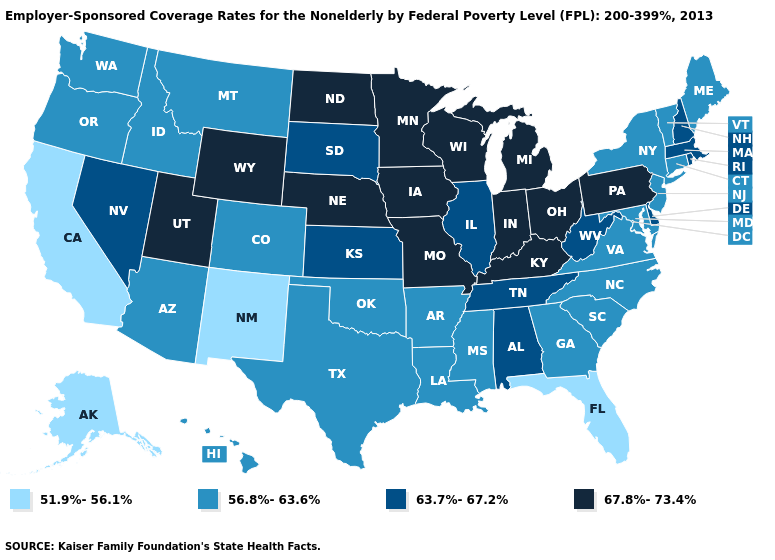What is the value of Colorado?
Quick response, please. 56.8%-63.6%. Does New Mexico have the lowest value in the USA?
Keep it brief. Yes. What is the highest value in the USA?
Answer briefly. 67.8%-73.4%. Does the map have missing data?
Answer briefly. No. Name the states that have a value in the range 56.8%-63.6%?
Answer briefly. Arizona, Arkansas, Colorado, Connecticut, Georgia, Hawaii, Idaho, Louisiana, Maine, Maryland, Mississippi, Montana, New Jersey, New York, North Carolina, Oklahoma, Oregon, South Carolina, Texas, Vermont, Virginia, Washington. Does Kentucky have the highest value in the South?
Concise answer only. Yes. Does North Dakota have a lower value than Minnesota?
Concise answer only. No. Name the states that have a value in the range 51.9%-56.1%?
Quick response, please. Alaska, California, Florida, New Mexico. Among the states that border Idaho , does Utah have the highest value?
Be succinct. Yes. Name the states that have a value in the range 56.8%-63.6%?
Answer briefly. Arizona, Arkansas, Colorado, Connecticut, Georgia, Hawaii, Idaho, Louisiana, Maine, Maryland, Mississippi, Montana, New Jersey, New York, North Carolina, Oklahoma, Oregon, South Carolina, Texas, Vermont, Virginia, Washington. Among the states that border New York , which have the highest value?
Concise answer only. Pennsylvania. Which states have the lowest value in the USA?
Keep it brief. Alaska, California, Florida, New Mexico. Does the first symbol in the legend represent the smallest category?
Give a very brief answer. Yes. Name the states that have a value in the range 51.9%-56.1%?
Give a very brief answer. Alaska, California, Florida, New Mexico. What is the value of Alaska?
Keep it brief. 51.9%-56.1%. 